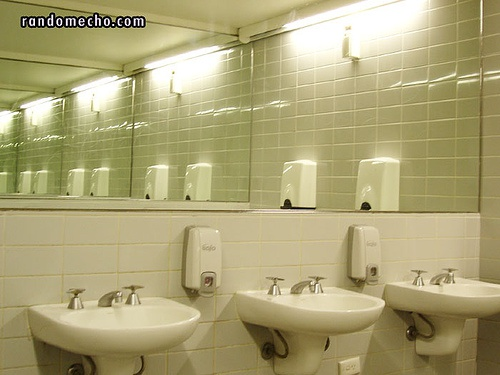Describe the objects in this image and their specific colors. I can see sink in olive and tan tones, sink in olive and tan tones, and sink in olive and beige tones in this image. 